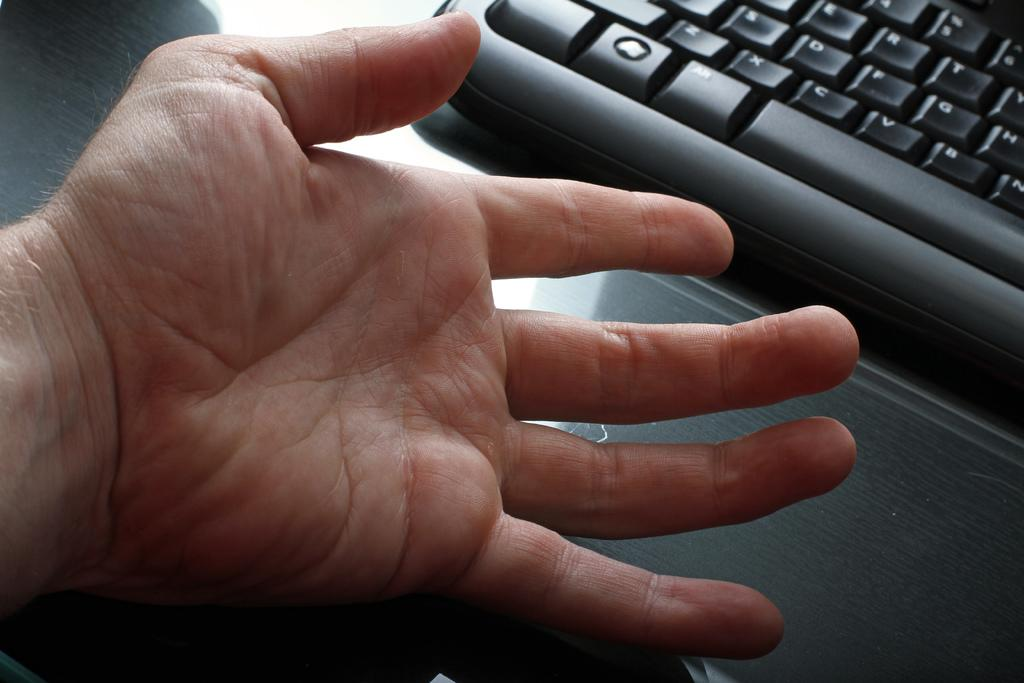<image>
Write a terse but informative summary of the picture. A person's hand is stretched out near the x, c, and v keys on a black keyboard. 